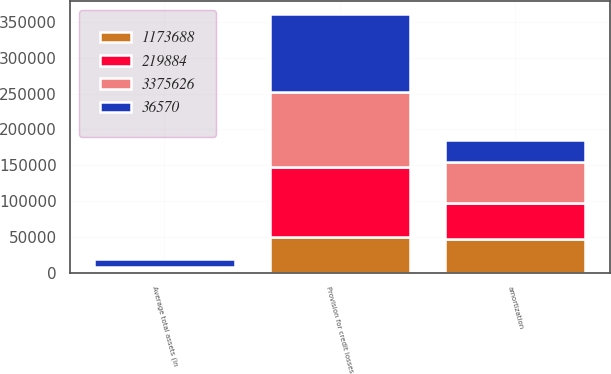Convert chart to OTSL. <chart><loc_0><loc_0><loc_500><loc_500><stacked_bar_chart><ecel><fcel>Provision for credit losses<fcel>amortization<fcel>Average total assets (in<nl><fcel>1.17369e+06<fcel>49110<fcel>46171<fcel>2217<nl><fcel>219884<fcel>97816<fcel>51552<fcel>2552<nl><fcel>3.37563e+06<fcel>104995<fcel>56666<fcel>2660<nl><fcel>36570<fcel>109978<fcel>31350<fcel>12079<nl></chart> 